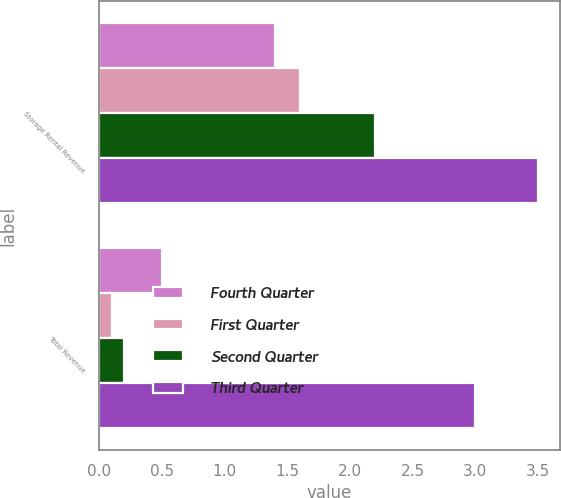<chart> <loc_0><loc_0><loc_500><loc_500><stacked_bar_chart><ecel><fcel>Storage Rental Revenue<fcel>Total Revenue<nl><fcel>Fourth Quarter<fcel>1.4<fcel>0.5<nl><fcel>First Quarter<fcel>1.6<fcel>0.1<nl><fcel>Second Quarter<fcel>2.2<fcel>0.2<nl><fcel>Third Quarter<fcel>3.5<fcel>3<nl></chart> 